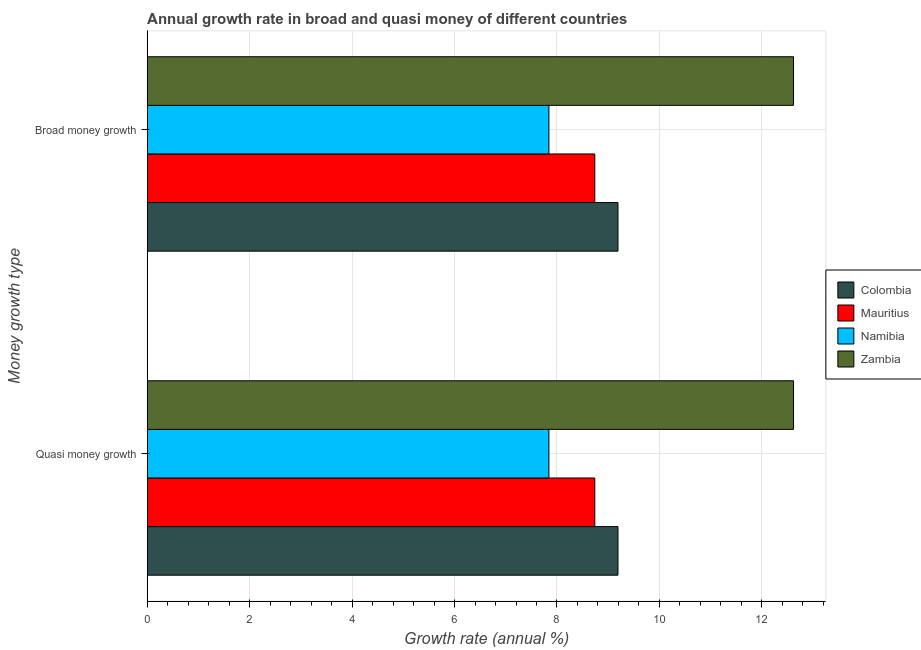How many different coloured bars are there?
Your answer should be very brief. 4. Are the number of bars per tick equal to the number of legend labels?
Provide a short and direct response. Yes. How many bars are there on the 2nd tick from the top?
Provide a short and direct response. 4. How many bars are there on the 2nd tick from the bottom?
Make the answer very short. 4. What is the label of the 2nd group of bars from the top?
Provide a succinct answer. Quasi money growth. What is the annual growth rate in broad money in Zambia?
Provide a succinct answer. 12.62. Across all countries, what is the maximum annual growth rate in broad money?
Your answer should be very brief. 12.62. Across all countries, what is the minimum annual growth rate in broad money?
Your answer should be compact. 7.84. In which country was the annual growth rate in quasi money maximum?
Offer a very short reply. Zambia. In which country was the annual growth rate in quasi money minimum?
Give a very brief answer. Namibia. What is the total annual growth rate in quasi money in the graph?
Provide a succinct answer. 38.39. What is the difference between the annual growth rate in broad money in Zambia and that in Namibia?
Provide a succinct answer. 4.78. What is the difference between the annual growth rate in quasi money in Mauritius and the annual growth rate in broad money in Zambia?
Offer a very short reply. -3.88. What is the average annual growth rate in quasi money per country?
Give a very brief answer. 9.6. What is the difference between the annual growth rate in quasi money and annual growth rate in broad money in Mauritius?
Provide a succinct answer. 0. What is the ratio of the annual growth rate in broad money in Zambia to that in Namibia?
Provide a short and direct response. 1.61. In how many countries, is the annual growth rate in broad money greater than the average annual growth rate in broad money taken over all countries?
Offer a very short reply. 1. What does the 3rd bar from the top in Broad money growth represents?
Give a very brief answer. Mauritius. What does the 4th bar from the bottom in Broad money growth represents?
Keep it short and to the point. Zambia. Are all the bars in the graph horizontal?
Keep it short and to the point. Yes. How many countries are there in the graph?
Your answer should be very brief. 4. Does the graph contain any zero values?
Provide a succinct answer. No. Where does the legend appear in the graph?
Make the answer very short. Center right. What is the title of the graph?
Ensure brevity in your answer.  Annual growth rate in broad and quasi money of different countries. What is the label or title of the X-axis?
Make the answer very short. Growth rate (annual %). What is the label or title of the Y-axis?
Offer a very short reply. Money growth type. What is the Growth rate (annual %) in Colombia in Quasi money growth?
Provide a succinct answer. 9.19. What is the Growth rate (annual %) of Mauritius in Quasi money growth?
Give a very brief answer. 8.74. What is the Growth rate (annual %) in Namibia in Quasi money growth?
Ensure brevity in your answer.  7.84. What is the Growth rate (annual %) in Zambia in Quasi money growth?
Provide a short and direct response. 12.62. What is the Growth rate (annual %) in Colombia in Broad money growth?
Your answer should be compact. 9.19. What is the Growth rate (annual %) in Mauritius in Broad money growth?
Provide a short and direct response. 8.74. What is the Growth rate (annual %) of Namibia in Broad money growth?
Ensure brevity in your answer.  7.84. What is the Growth rate (annual %) of Zambia in Broad money growth?
Offer a terse response. 12.62. Across all Money growth type, what is the maximum Growth rate (annual %) in Colombia?
Your response must be concise. 9.19. Across all Money growth type, what is the maximum Growth rate (annual %) in Mauritius?
Provide a succinct answer. 8.74. Across all Money growth type, what is the maximum Growth rate (annual %) in Namibia?
Your answer should be very brief. 7.84. Across all Money growth type, what is the maximum Growth rate (annual %) in Zambia?
Your response must be concise. 12.62. Across all Money growth type, what is the minimum Growth rate (annual %) of Colombia?
Your answer should be very brief. 9.19. Across all Money growth type, what is the minimum Growth rate (annual %) of Mauritius?
Give a very brief answer. 8.74. Across all Money growth type, what is the minimum Growth rate (annual %) in Namibia?
Give a very brief answer. 7.84. Across all Money growth type, what is the minimum Growth rate (annual %) in Zambia?
Provide a short and direct response. 12.62. What is the total Growth rate (annual %) of Colombia in the graph?
Give a very brief answer. 18.38. What is the total Growth rate (annual %) in Mauritius in the graph?
Ensure brevity in your answer.  17.48. What is the total Growth rate (annual %) in Namibia in the graph?
Ensure brevity in your answer.  15.69. What is the total Growth rate (annual %) of Zambia in the graph?
Your response must be concise. 25.24. What is the difference between the Growth rate (annual %) in Namibia in Quasi money growth and that in Broad money growth?
Give a very brief answer. 0. What is the difference between the Growth rate (annual %) in Colombia in Quasi money growth and the Growth rate (annual %) in Mauritius in Broad money growth?
Offer a very short reply. 0.45. What is the difference between the Growth rate (annual %) in Colombia in Quasi money growth and the Growth rate (annual %) in Namibia in Broad money growth?
Your answer should be compact. 1.35. What is the difference between the Growth rate (annual %) of Colombia in Quasi money growth and the Growth rate (annual %) of Zambia in Broad money growth?
Make the answer very short. -3.43. What is the difference between the Growth rate (annual %) of Mauritius in Quasi money growth and the Growth rate (annual %) of Namibia in Broad money growth?
Keep it short and to the point. 0.9. What is the difference between the Growth rate (annual %) in Mauritius in Quasi money growth and the Growth rate (annual %) in Zambia in Broad money growth?
Offer a terse response. -3.88. What is the difference between the Growth rate (annual %) in Namibia in Quasi money growth and the Growth rate (annual %) in Zambia in Broad money growth?
Your answer should be compact. -4.78. What is the average Growth rate (annual %) of Colombia per Money growth type?
Give a very brief answer. 9.19. What is the average Growth rate (annual %) of Mauritius per Money growth type?
Provide a short and direct response. 8.74. What is the average Growth rate (annual %) in Namibia per Money growth type?
Make the answer very short. 7.84. What is the average Growth rate (annual %) of Zambia per Money growth type?
Your answer should be compact. 12.62. What is the difference between the Growth rate (annual %) in Colombia and Growth rate (annual %) in Mauritius in Quasi money growth?
Your answer should be very brief. 0.45. What is the difference between the Growth rate (annual %) of Colombia and Growth rate (annual %) of Namibia in Quasi money growth?
Keep it short and to the point. 1.35. What is the difference between the Growth rate (annual %) in Colombia and Growth rate (annual %) in Zambia in Quasi money growth?
Your response must be concise. -3.43. What is the difference between the Growth rate (annual %) in Mauritius and Growth rate (annual %) in Namibia in Quasi money growth?
Your answer should be compact. 0.9. What is the difference between the Growth rate (annual %) in Mauritius and Growth rate (annual %) in Zambia in Quasi money growth?
Your answer should be compact. -3.88. What is the difference between the Growth rate (annual %) in Namibia and Growth rate (annual %) in Zambia in Quasi money growth?
Your answer should be compact. -4.78. What is the difference between the Growth rate (annual %) of Colombia and Growth rate (annual %) of Mauritius in Broad money growth?
Your answer should be very brief. 0.45. What is the difference between the Growth rate (annual %) in Colombia and Growth rate (annual %) in Namibia in Broad money growth?
Your response must be concise. 1.35. What is the difference between the Growth rate (annual %) of Colombia and Growth rate (annual %) of Zambia in Broad money growth?
Provide a succinct answer. -3.43. What is the difference between the Growth rate (annual %) of Mauritius and Growth rate (annual %) of Namibia in Broad money growth?
Keep it short and to the point. 0.9. What is the difference between the Growth rate (annual %) in Mauritius and Growth rate (annual %) in Zambia in Broad money growth?
Your answer should be very brief. -3.88. What is the difference between the Growth rate (annual %) of Namibia and Growth rate (annual %) of Zambia in Broad money growth?
Make the answer very short. -4.78. What is the ratio of the Growth rate (annual %) of Colombia in Quasi money growth to that in Broad money growth?
Ensure brevity in your answer.  1. What is the ratio of the Growth rate (annual %) of Mauritius in Quasi money growth to that in Broad money growth?
Give a very brief answer. 1. What is the ratio of the Growth rate (annual %) of Namibia in Quasi money growth to that in Broad money growth?
Offer a terse response. 1. What is the ratio of the Growth rate (annual %) in Zambia in Quasi money growth to that in Broad money growth?
Offer a very short reply. 1. What is the difference between the highest and the second highest Growth rate (annual %) of Colombia?
Ensure brevity in your answer.  0. What is the difference between the highest and the lowest Growth rate (annual %) of Namibia?
Provide a succinct answer. 0. 